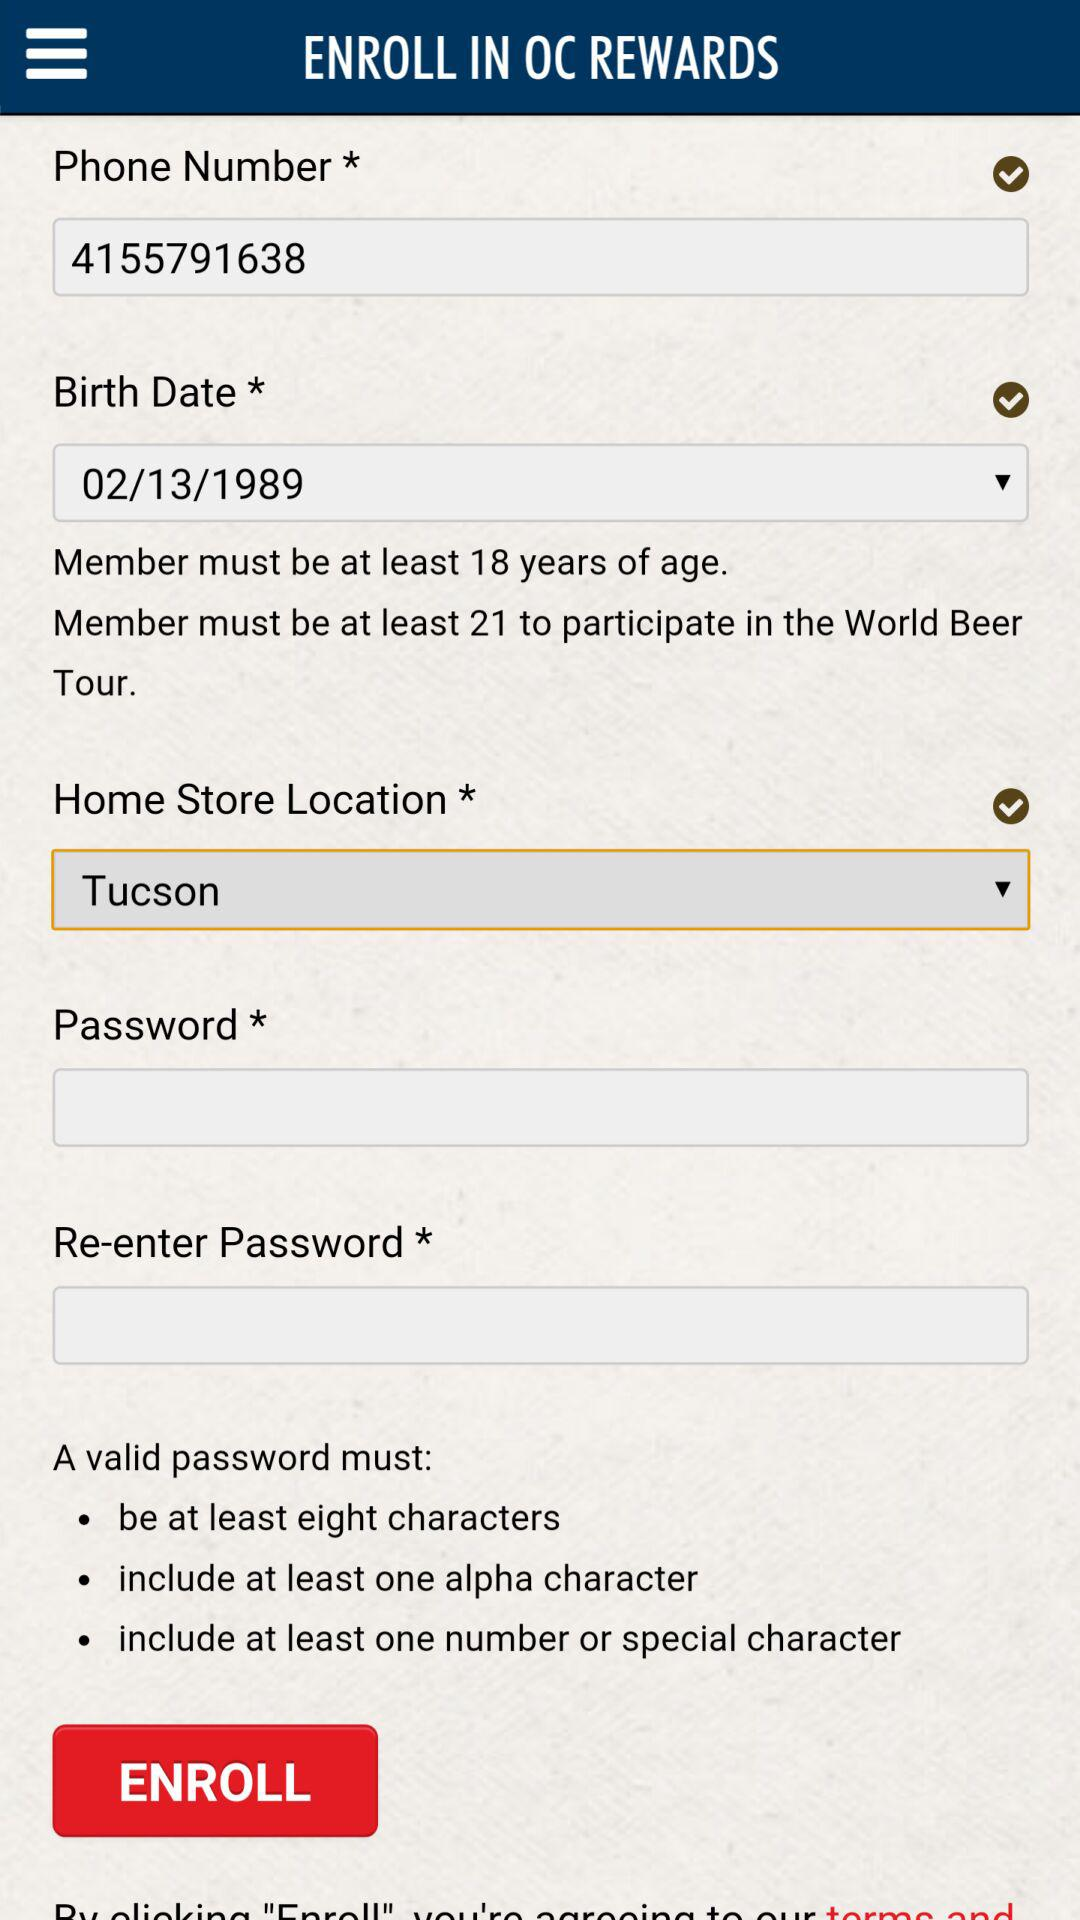What are the instructions for a valid password? The instructions for a valid password are that it must be at least eight characters long, include at least one alpha character and include at least one number or special character. 